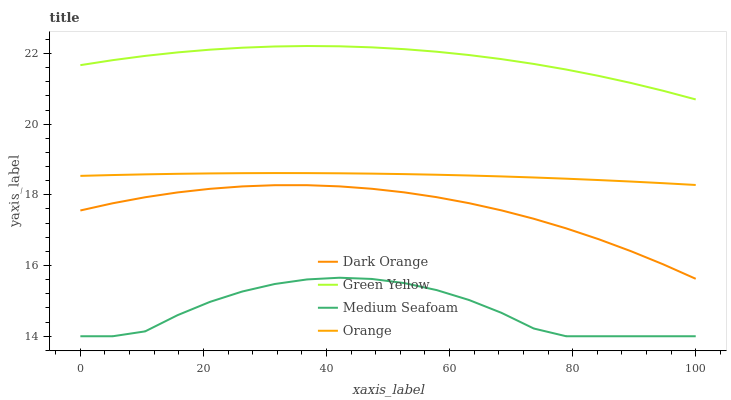Does Medium Seafoam have the minimum area under the curve?
Answer yes or no. Yes. Does Green Yellow have the maximum area under the curve?
Answer yes or no. Yes. Does Dark Orange have the minimum area under the curve?
Answer yes or no. No. Does Dark Orange have the maximum area under the curve?
Answer yes or no. No. Is Orange the smoothest?
Answer yes or no. Yes. Is Medium Seafoam the roughest?
Answer yes or no. Yes. Is Dark Orange the smoothest?
Answer yes or no. No. Is Dark Orange the roughest?
Answer yes or no. No. Does Medium Seafoam have the lowest value?
Answer yes or no. Yes. Does Dark Orange have the lowest value?
Answer yes or no. No. Does Green Yellow have the highest value?
Answer yes or no. Yes. Does Dark Orange have the highest value?
Answer yes or no. No. Is Medium Seafoam less than Green Yellow?
Answer yes or no. Yes. Is Orange greater than Dark Orange?
Answer yes or no. Yes. Does Medium Seafoam intersect Green Yellow?
Answer yes or no. No. 